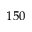<formula> <loc_0><loc_0><loc_500><loc_500>1 5 0</formula> 